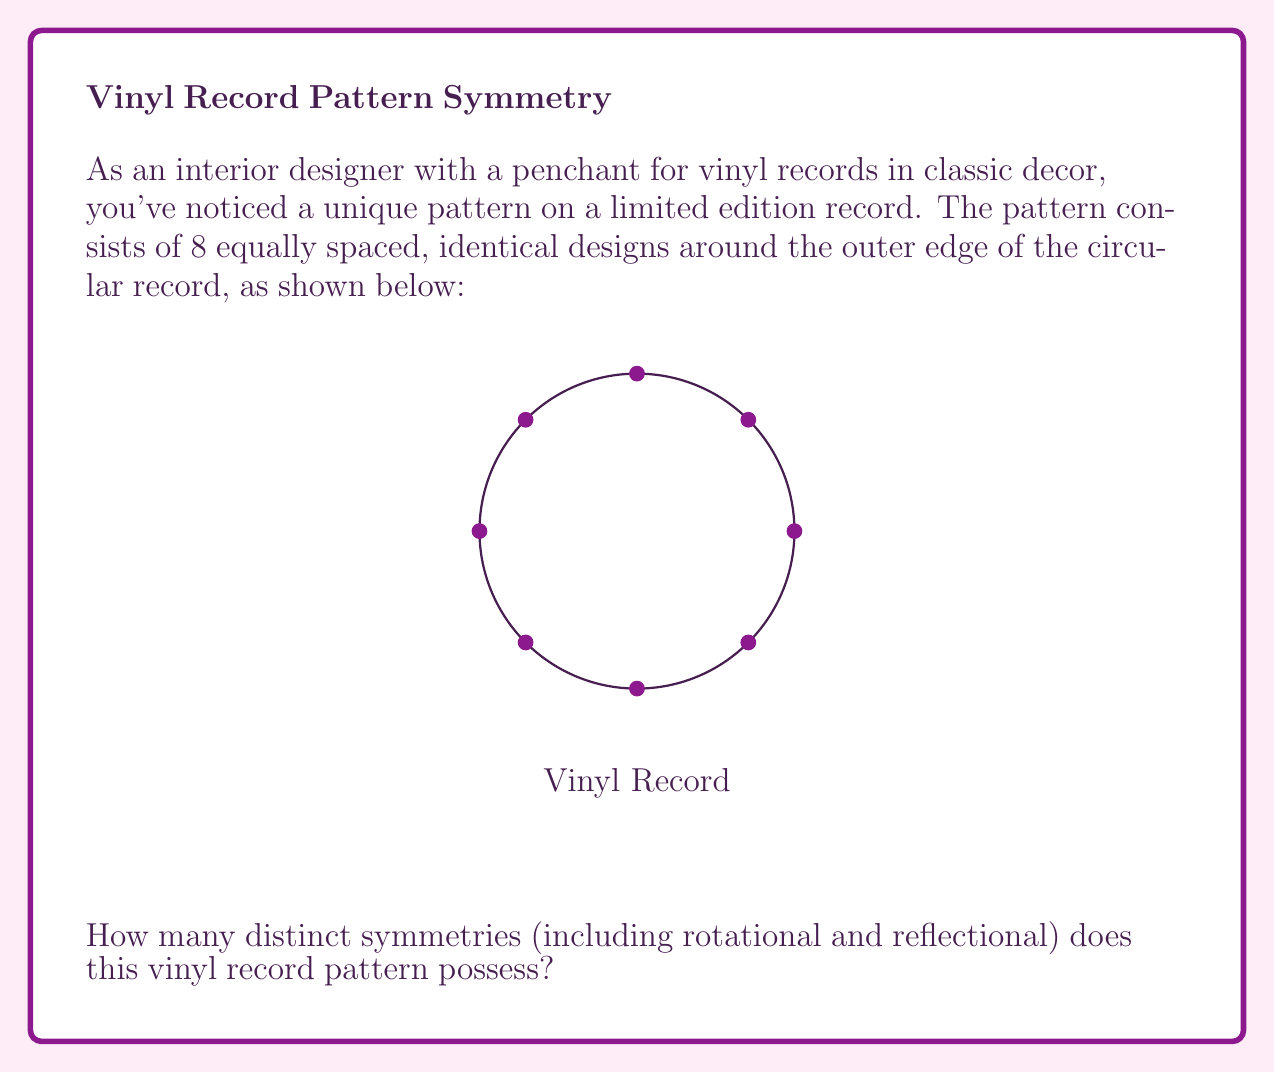Solve this math problem. To determine the number of symmetries in this circular vinyl record pattern, we need to consider both rotational and reflectional symmetries:

1. Rotational Symmetries:
   - The pattern has 8 identical designs equally spaced around the circle.
   - This means we can rotate the record by multiples of 45° (360°/8) to obtain the same pattern.
   - There are 8 distinct rotations: 0°, 45°, 90°, 135°, 180°, 225°, 270°, and 315°.

2. Reflectional Symmetries:
   - There are 8 lines of reflection in this pattern.
   - 4 lines pass through opposite designs (like diameters of the circle).
   - 4 lines pass between adjacent designs (like angle bisectors).

3. Total Symmetries:
   - The total number of symmetries is the sum of rotational and reflectional symmetries.
   - Number of symmetries = 8 (rotational) + 8 (reflectional) = 16

In group theory terms, this symmetry group is known as the dihedral group $D_8$, which has order 16.
Answer: 16 